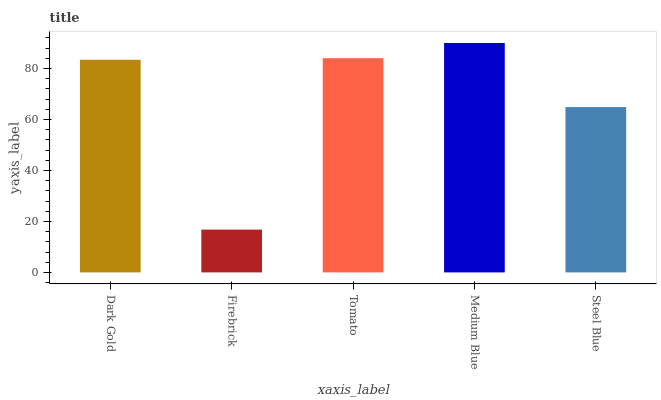Is Firebrick the minimum?
Answer yes or no. Yes. Is Medium Blue the maximum?
Answer yes or no. Yes. Is Tomato the minimum?
Answer yes or no. No. Is Tomato the maximum?
Answer yes or no. No. Is Tomato greater than Firebrick?
Answer yes or no. Yes. Is Firebrick less than Tomato?
Answer yes or no. Yes. Is Firebrick greater than Tomato?
Answer yes or no. No. Is Tomato less than Firebrick?
Answer yes or no. No. Is Dark Gold the high median?
Answer yes or no. Yes. Is Dark Gold the low median?
Answer yes or no. Yes. Is Firebrick the high median?
Answer yes or no. No. Is Medium Blue the low median?
Answer yes or no. No. 